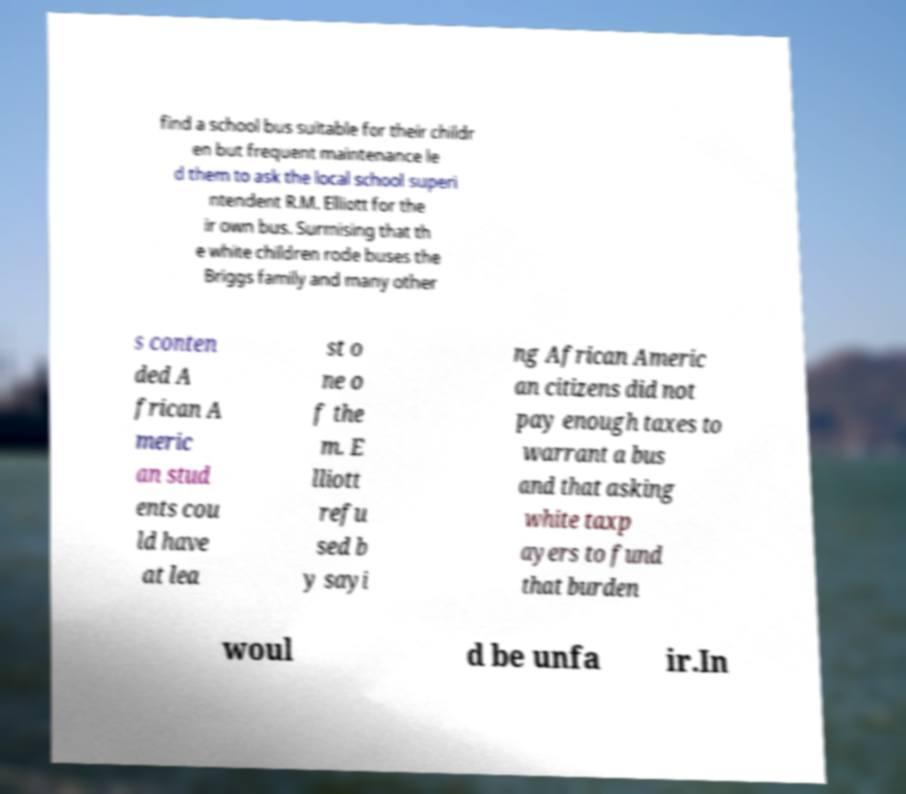There's text embedded in this image that I need extracted. Can you transcribe it verbatim? find a school bus suitable for their childr en but frequent maintenance le d them to ask the local school superi ntendent R.M. Elliott for the ir own bus. Surmising that th e white children rode buses the Briggs family and many other s conten ded A frican A meric an stud ents cou ld have at lea st o ne o f the m. E lliott refu sed b y sayi ng African Americ an citizens did not pay enough taxes to warrant a bus and that asking white taxp ayers to fund that burden woul d be unfa ir.In 